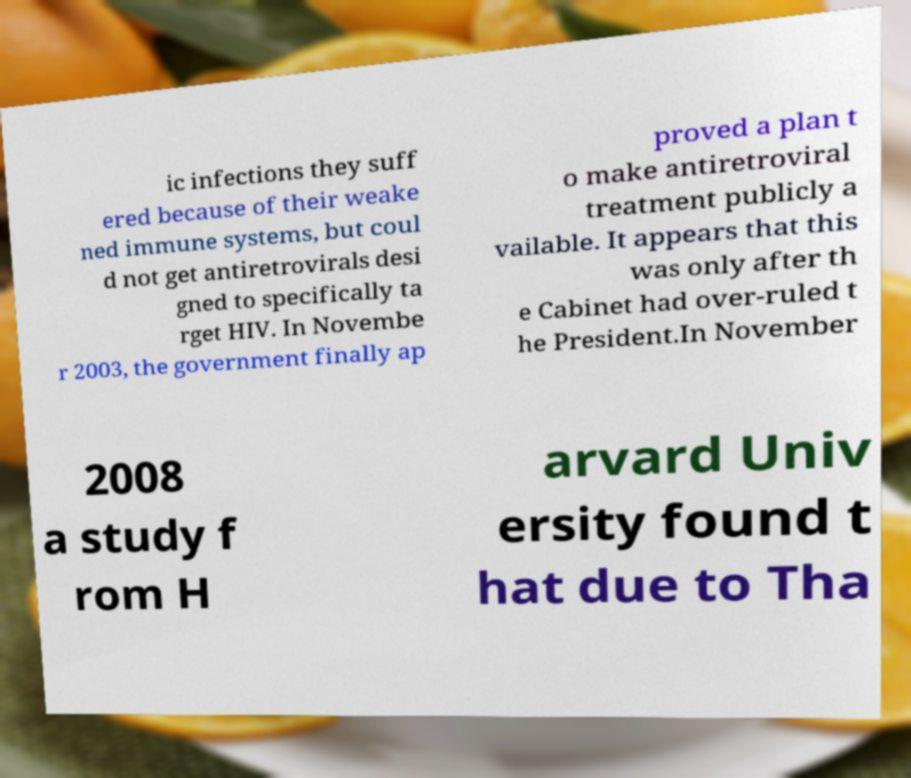Can you accurately transcribe the text from the provided image for me? ic infections they suff ered because of their weake ned immune systems, but coul d not get antiretrovirals desi gned to specifically ta rget HIV. In Novembe r 2003, the government finally ap proved a plan t o make antiretroviral treatment publicly a vailable. It appears that this was only after th e Cabinet had over-ruled t he President.In November 2008 a study f rom H arvard Univ ersity found t hat due to Tha 